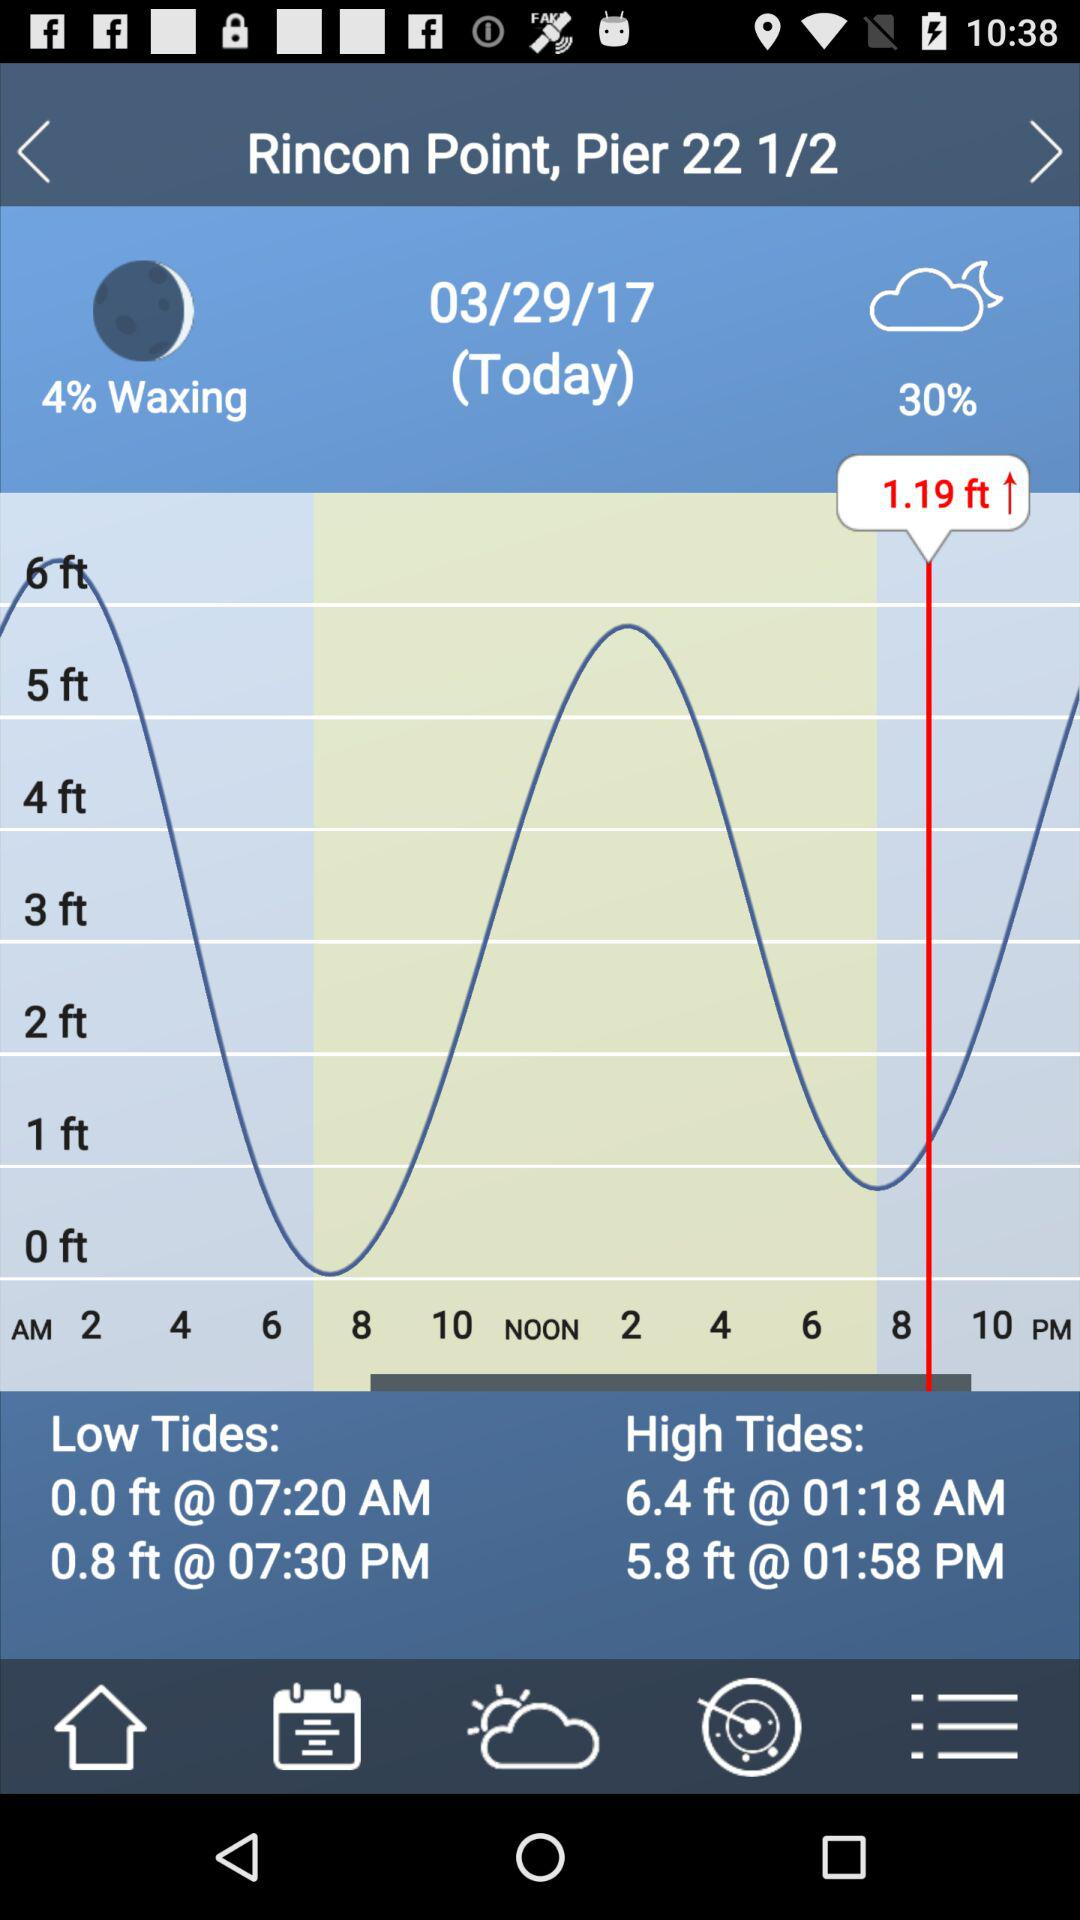What is the mentioned height of low tides? The mentioned heights are 0.0 ft and 0.8 ft. 